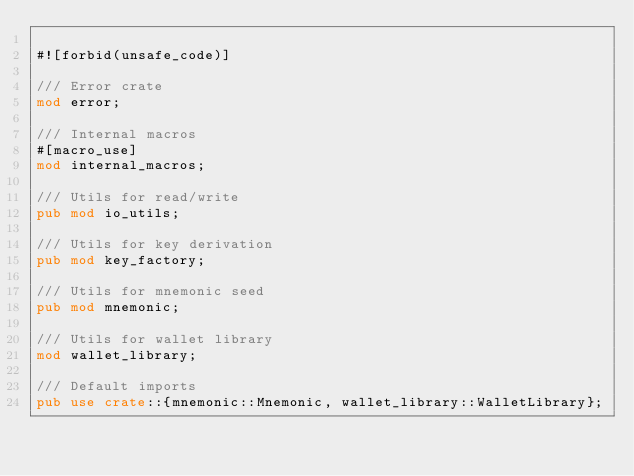Convert code to text. <code><loc_0><loc_0><loc_500><loc_500><_Rust_>
#![forbid(unsafe_code)]

/// Error crate
mod error;

/// Internal macros
#[macro_use]
mod internal_macros;

/// Utils for read/write
pub mod io_utils;

/// Utils for key derivation
pub mod key_factory;

/// Utils for mnemonic seed
pub mod mnemonic;

/// Utils for wallet library
mod wallet_library;

/// Default imports
pub use crate::{mnemonic::Mnemonic, wallet_library::WalletLibrary};
</code> 